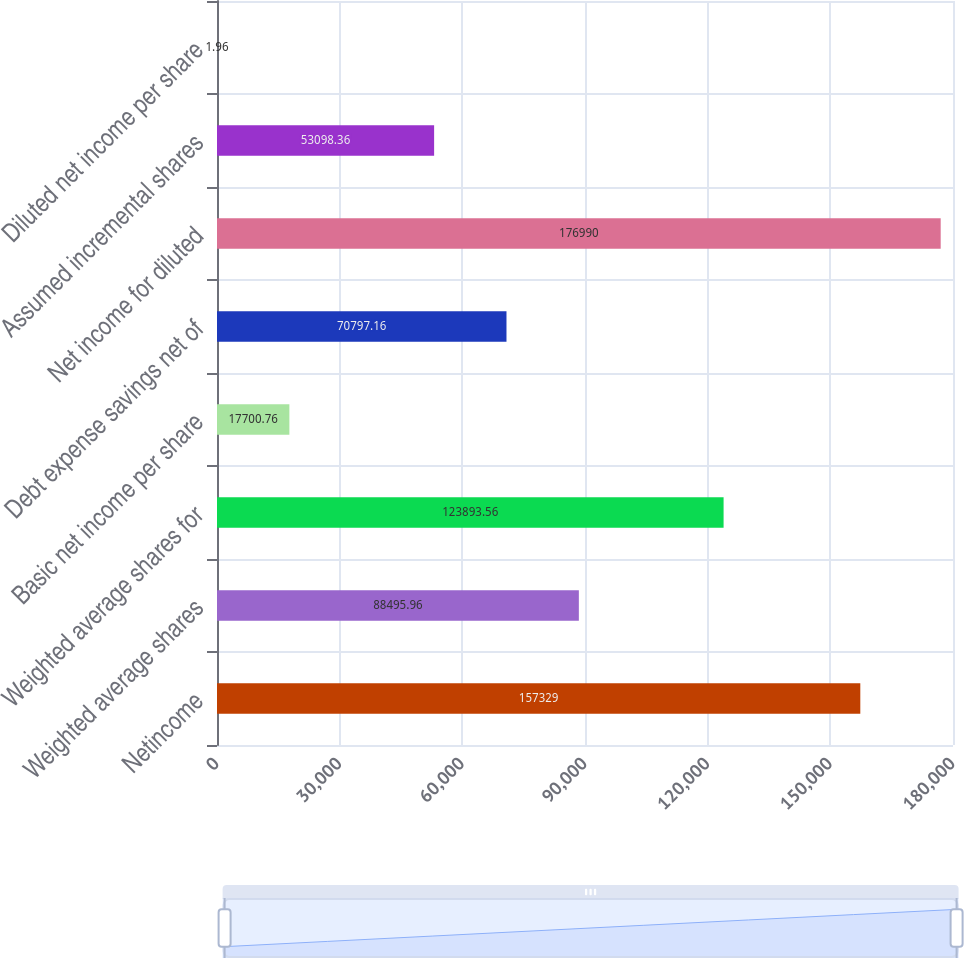Convert chart to OTSL. <chart><loc_0><loc_0><loc_500><loc_500><bar_chart><fcel>Netincome<fcel>Weighted average shares<fcel>Weighted average shares for<fcel>Basic net income per share<fcel>Debt expense savings net of<fcel>Net income for diluted<fcel>Assumed incremental shares<fcel>Diluted net income per share<nl><fcel>157329<fcel>88496<fcel>123894<fcel>17700.8<fcel>70797.2<fcel>176990<fcel>53098.4<fcel>1.96<nl></chart> 